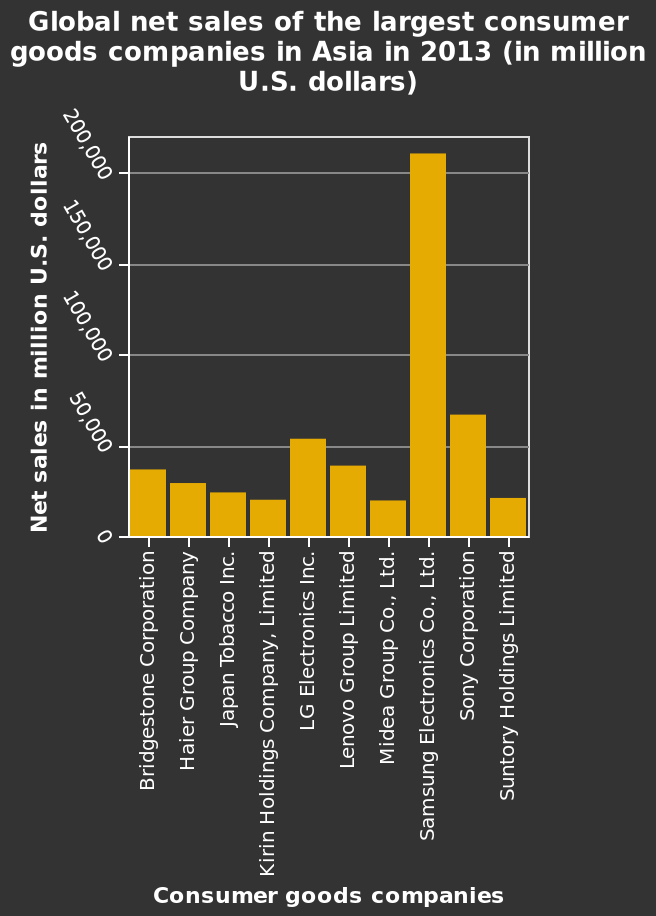<image>
What is the lowest consumer goods company mentioned in the bar diagram? Bridgestone Corporation is the lowest consumer goods company mentioned in the bar diagram. What is the lowest net sales amount for consumer goods companies?  The lowest net sales amount for consumer goods companies is $0.3 billion. What is the net sales value for Bridgestone Corporation in 2013? The net sales value for Bridgestone Corporation in 2013 is not provided in the given information. Describe the following image in detail Global net sales of the largest consumer goods companies in Asia in 2013 (in million U.S. dollars) is a bar diagram. A linear scale of range 0 to 200,000 can be found on the y-axis, labeled Net sales in million U.S. dollars. There is a categorical scale starting with Bridgestone Corporation and ending with Suntory Holdings Limited along the x-axis, marked Consumer goods companies. 